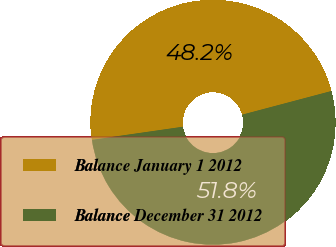<chart> <loc_0><loc_0><loc_500><loc_500><pie_chart><fcel>Balance January 1 2012<fcel>Balance December 31 2012<nl><fcel>48.15%<fcel>51.85%<nl></chart> 